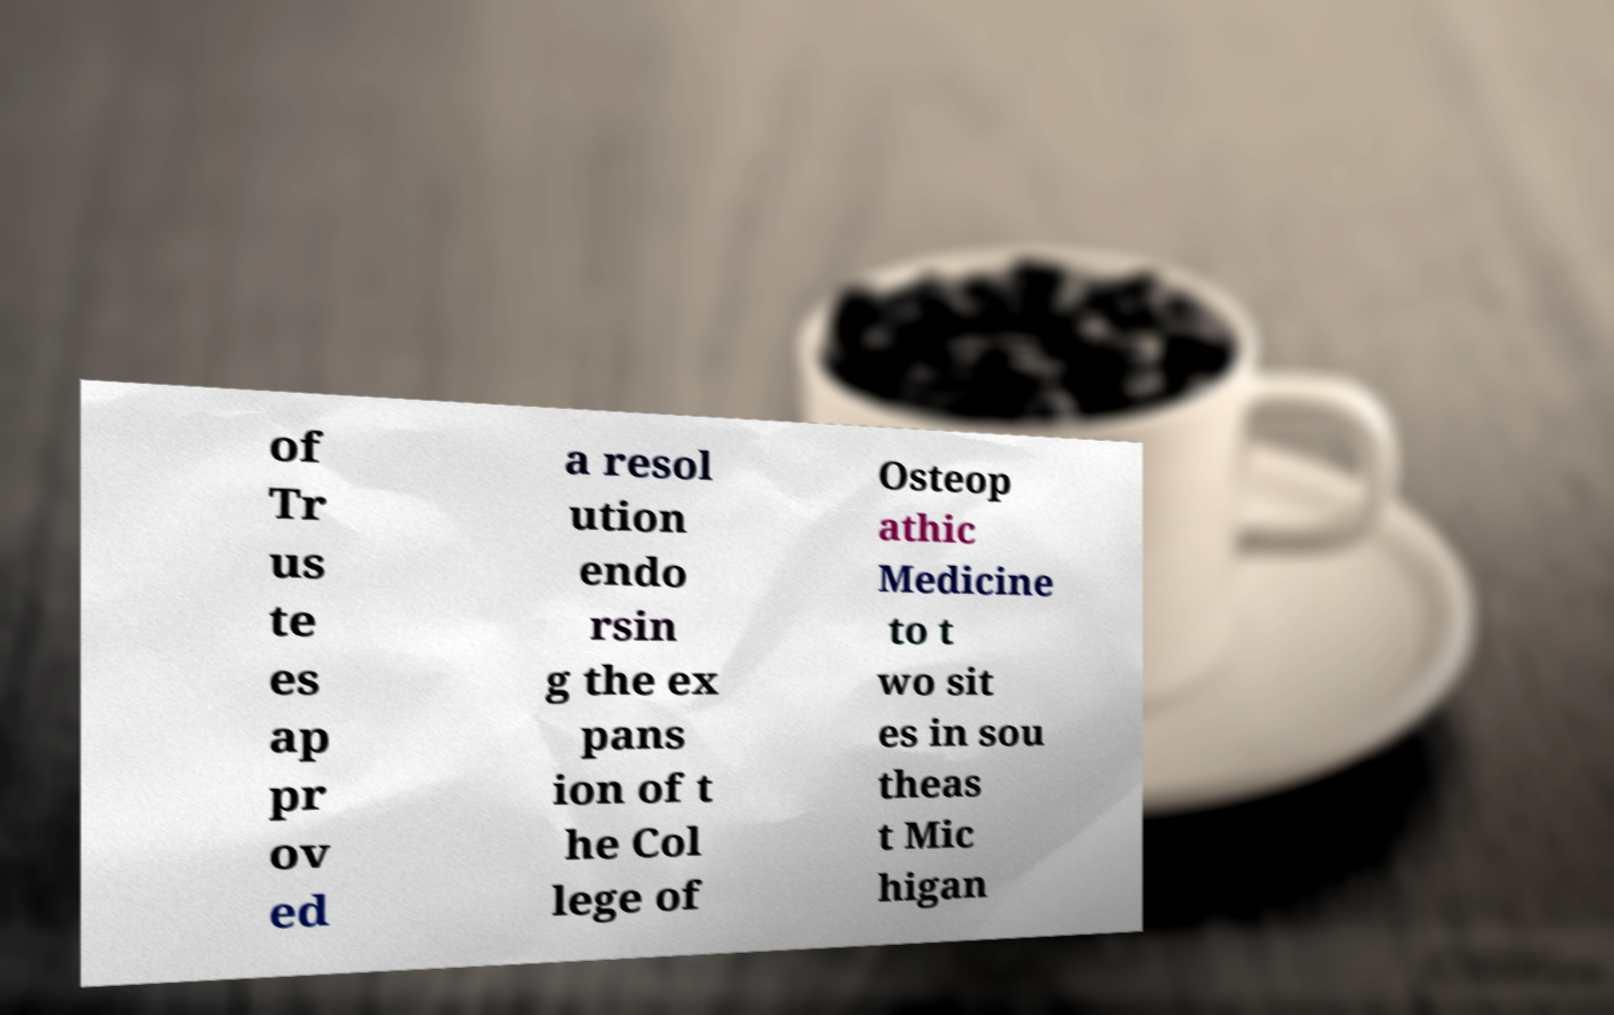I need the written content from this picture converted into text. Can you do that? of Tr us te es ap pr ov ed a resol ution endo rsin g the ex pans ion of t he Col lege of Osteop athic Medicine to t wo sit es in sou theas t Mic higan 